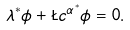Convert formula to latex. <formula><loc_0><loc_0><loc_500><loc_500>\lambda ^ { * } \phi + \L c ^ { \alpha ^ { * } } { \phi } = 0 .</formula> 